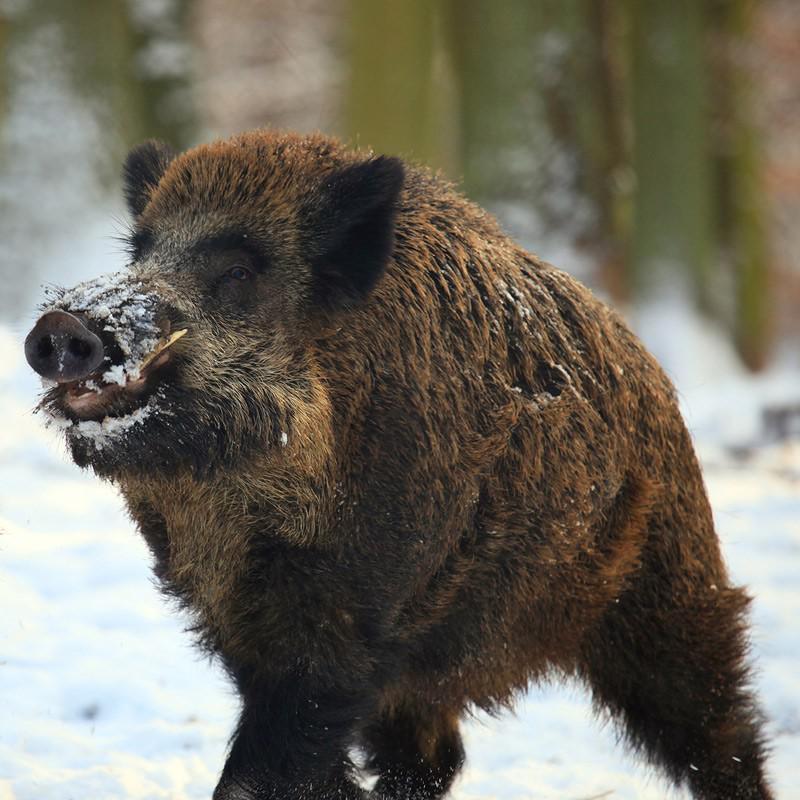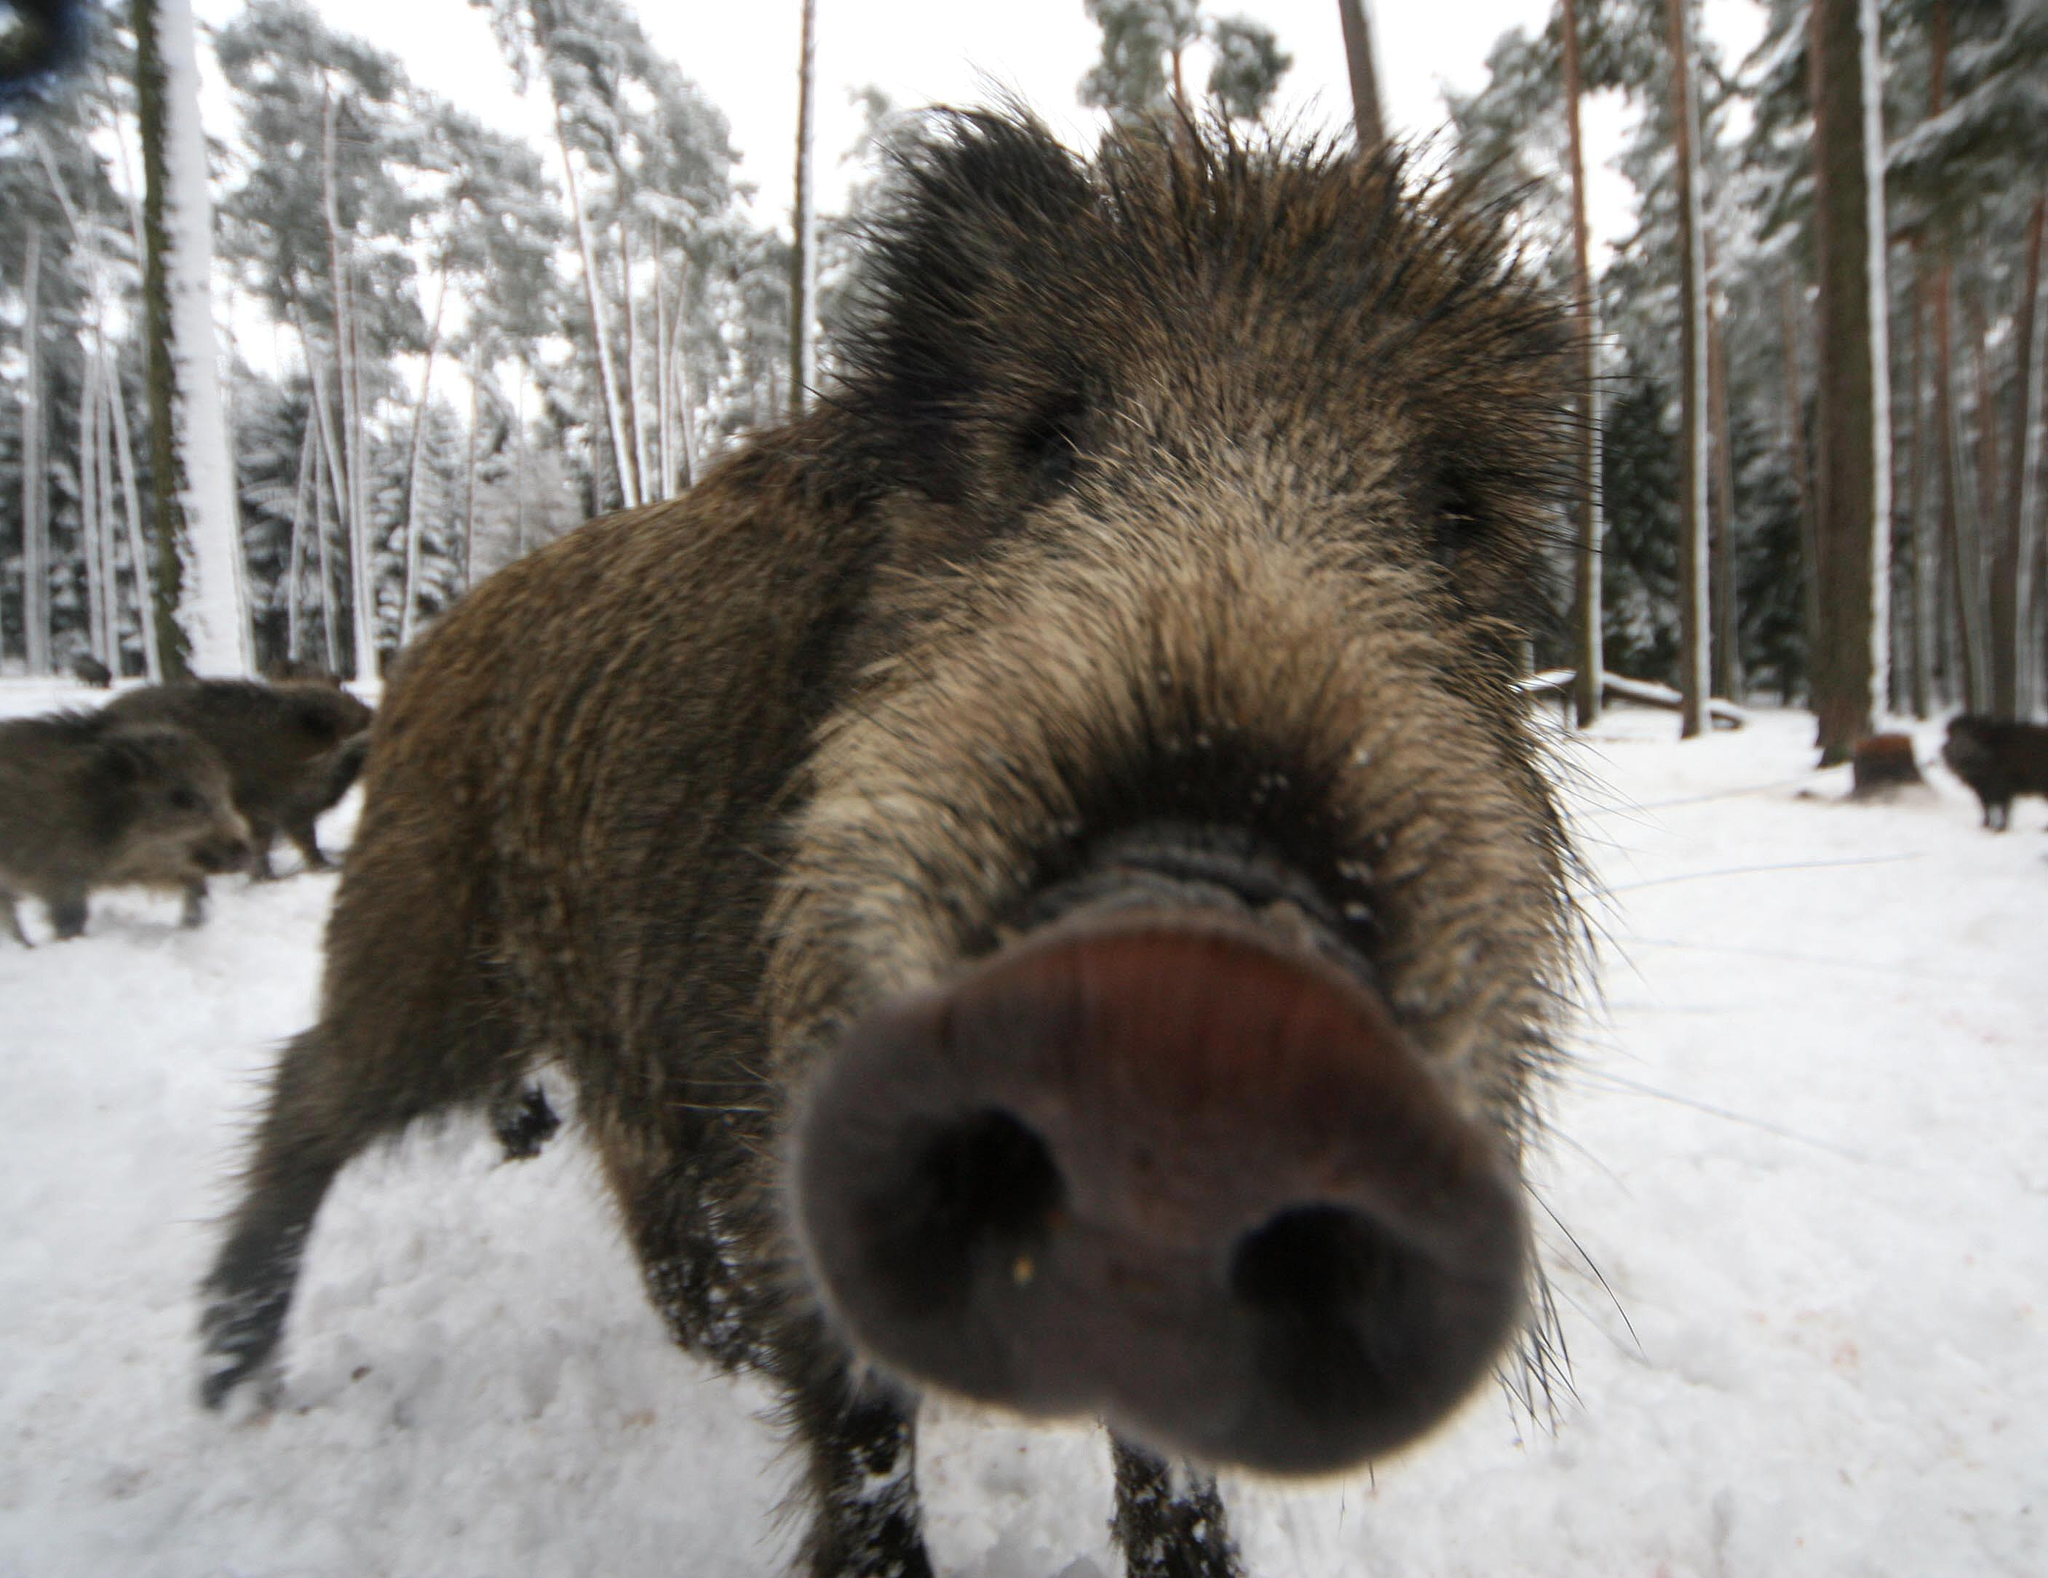The first image is the image on the left, the second image is the image on the right. Analyze the images presented: Is the assertion "There is more than one animal species in the image." valid? Answer yes or no. No. The first image is the image on the left, the second image is the image on the right. Analyze the images presented: Is the assertion "The left image contains exactly one wild boar." valid? Answer yes or no. Yes. 